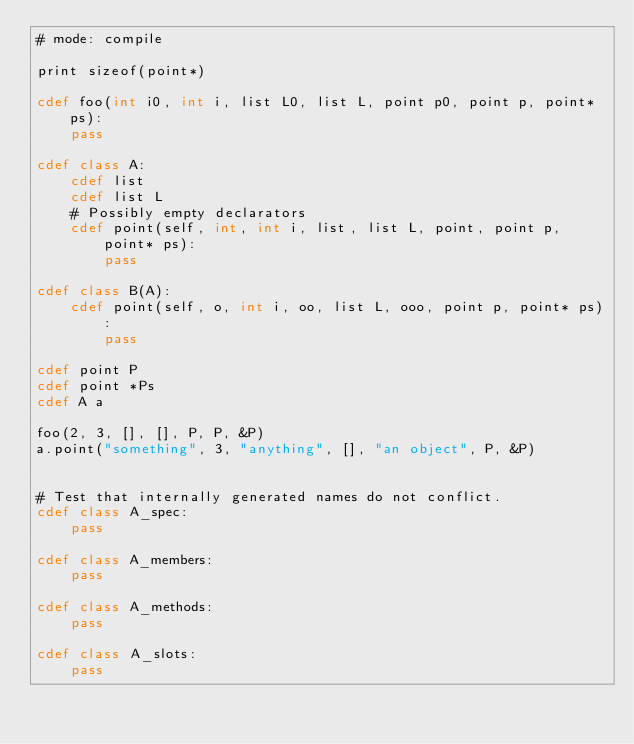Convert code to text. <code><loc_0><loc_0><loc_500><loc_500><_Cython_># mode: compile

print sizeof(point*)

cdef foo(int i0, int i, list L0, list L, point p0, point p, point* ps):
    pass

cdef class A:
    cdef list
    cdef list L
    # Possibly empty declarators
    cdef point(self, int, int i, list, list L, point, point p, point* ps):
        pass

cdef class B(A):
    cdef point(self, o, int i, oo, list L, ooo, point p, point* ps):
        pass

cdef point P
cdef point *Ps
cdef A a

foo(2, 3, [], [], P, P, &P)
a.point("something", 3, "anything", [], "an object", P, &P)


# Test that internally generated names do not conflict.
cdef class A_spec:
    pass

cdef class A_members:
    pass

cdef class A_methods:
    pass

cdef class A_slots:
    pass
</code> 